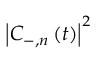<formula> <loc_0><loc_0><loc_500><loc_500>\left | C _ { - , n } \left ( t \right ) \right | ^ { 2 }</formula> 